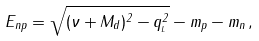Convert formula to latex. <formula><loc_0><loc_0><loc_500><loc_500>E _ { n p } = \sqrt { ( \nu + M _ { d } ) ^ { 2 } - q _ { _ { L } } ^ { 2 } } - m _ { p } - m _ { n } \, ,</formula> 